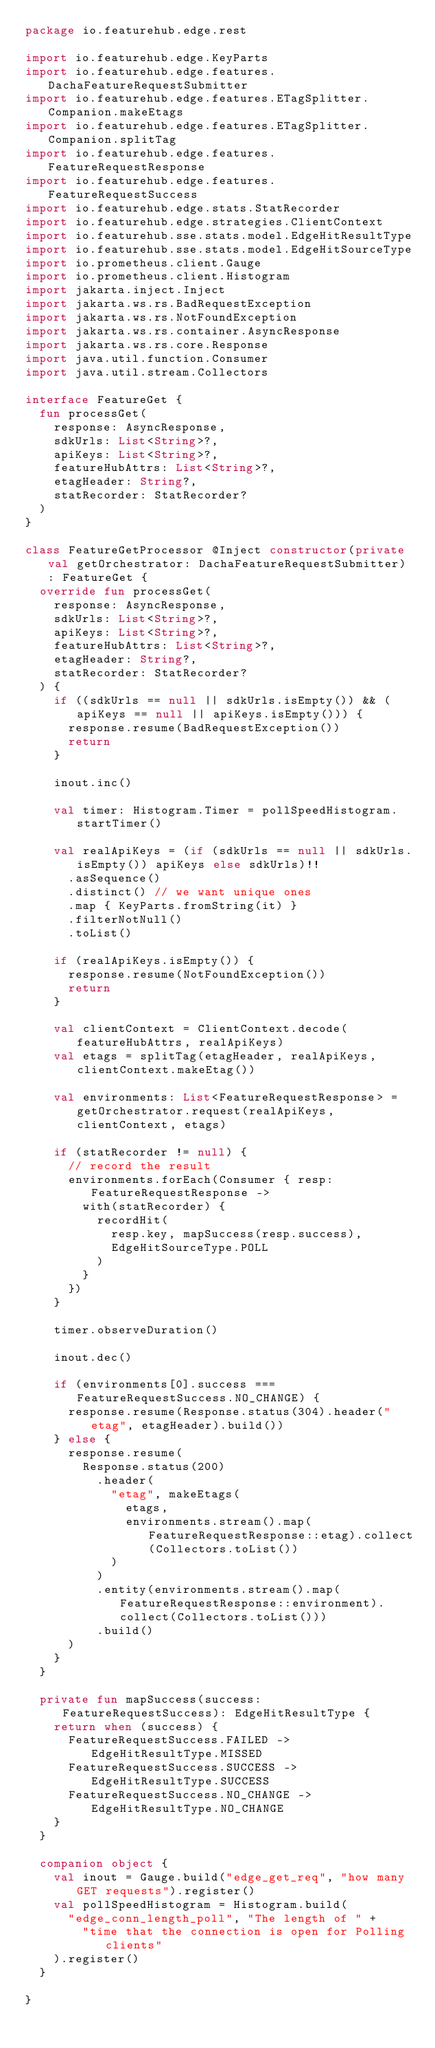<code> <loc_0><loc_0><loc_500><loc_500><_Kotlin_>package io.featurehub.edge.rest

import io.featurehub.edge.KeyParts
import io.featurehub.edge.features.DachaFeatureRequestSubmitter
import io.featurehub.edge.features.ETagSplitter.Companion.makeEtags
import io.featurehub.edge.features.ETagSplitter.Companion.splitTag
import io.featurehub.edge.features.FeatureRequestResponse
import io.featurehub.edge.features.FeatureRequestSuccess
import io.featurehub.edge.stats.StatRecorder
import io.featurehub.edge.strategies.ClientContext
import io.featurehub.sse.stats.model.EdgeHitResultType
import io.featurehub.sse.stats.model.EdgeHitSourceType
import io.prometheus.client.Gauge
import io.prometheus.client.Histogram
import jakarta.inject.Inject
import jakarta.ws.rs.BadRequestException
import jakarta.ws.rs.NotFoundException
import jakarta.ws.rs.container.AsyncResponse
import jakarta.ws.rs.core.Response
import java.util.function.Consumer
import java.util.stream.Collectors

interface FeatureGet {
  fun processGet(
    response: AsyncResponse,
    sdkUrls: List<String>?,
    apiKeys: List<String>?,
    featureHubAttrs: List<String>?,
    etagHeader: String?,
    statRecorder: StatRecorder?
  )
}

class FeatureGetProcessor @Inject constructor(private val getOrchestrator: DachaFeatureRequestSubmitter) : FeatureGet {
  override fun processGet(
    response: AsyncResponse,
    sdkUrls: List<String>?,
    apiKeys: List<String>?,
    featureHubAttrs: List<String>?,
    etagHeader: String?,
    statRecorder: StatRecorder?
  ) {
    if ((sdkUrls == null || sdkUrls.isEmpty()) && (apiKeys == null || apiKeys.isEmpty())) {
      response.resume(BadRequestException())
      return
    }

    inout.inc()

    val timer: Histogram.Timer = pollSpeedHistogram.startTimer()

    val realApiKeys = (if (sdkUrls == null || sdkUrls.isEmpty()) apiKeys else sdkUrls)!!
      .asSequence()
      .distinct() // we want unique ones
      .map { KeyParts.fromString(it) }
      .filterNotNull()
      .toList()

    if (realApiKeys.isEmpty()) {
      response.resume(NotFoundException())
      return
    }

    val clientContext = ClientContext.decode(featureHubAttrs, realApiKeys)
    val etags = splitTag(etagHeader, realApiKeys, clientContext.makeEtag())

    val environments: List<FeatureRequestResponse> = getOrchestrator.request(realApiKeys, clientContext, etags)

    if (statRecorder != null) {
      // record the result
      environments.forEach(Consumer { resp: FeatureRequestResponse ->
        with(statRecorder) {
          recordHit(
            resp.key, mapSuccess(resp.success),
            EdgeHitSourceType.POLL
          )
        }
      })
    }

    timer.observeDuration()

    inout.dec()

    if (environments[0].success === FeatureRequestSuccess.NO_CHANGE) {
      response.resume(Response.status(304).header("etag", etagHeader).build())
    } else {
      response.resume(
        Response.status(200)
          .header(
            "etag", makeEtags(
              etags,
              environments.stream().map(FeatureRequestResponse::etag).collect(Collectors.toList())
            )
          )
          .entity(environments.stream().map(FeatureRequestResponse::environment).collect(Collectors.toList()))
          .build()
      )
    }
  }

  private fun mapSuccess(success: FeatureRequestSuccess): EdgeHitResultType {
    return when (success) {
      FeatureRequestSuccess.FAILED -> EdgeHitResultType.MISSED
      FeatureRequestSuccess.SUCCESS -> EdgeHitResultType.SUCCESS
      FeatureRequestSuccess.NO_CHANGE -> EdgeHitResultType.NO_CHANGE
    }
  }

  companion object {
    val inout = Gauge.build("edge_get_req", "how many GET requests").register()
    val pollSpeedHistogram = Histogram.build(
      "edge_conn_length_poll", "The length of " +
        "time that the connection is open for Polling clients"
    ).register()
  }

}
</code> 